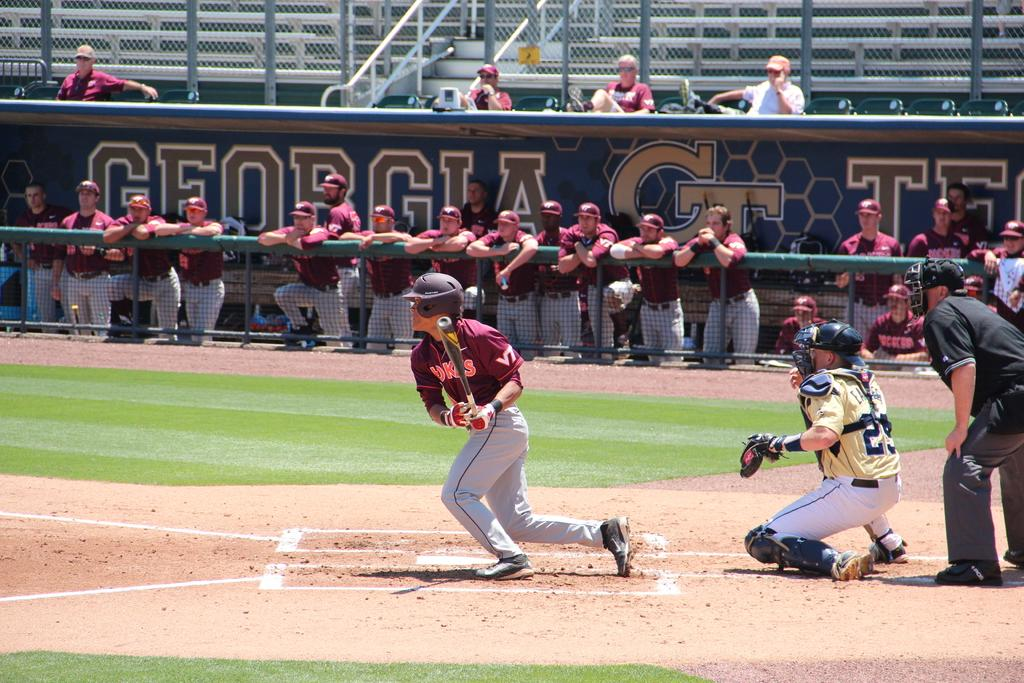<image>
Create a compact narrative representing the image presented. A baseball game is going on at the Georgia team's stadium. 